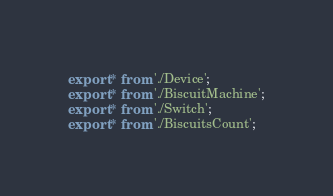<code> <loc_0><loc_0><loc_500><loc_500><_JavaScript_>export * from './Device';
export * from './BiscuitMachine';
export * from './Switch';
export * from './BiscuitsCount';
</code> 